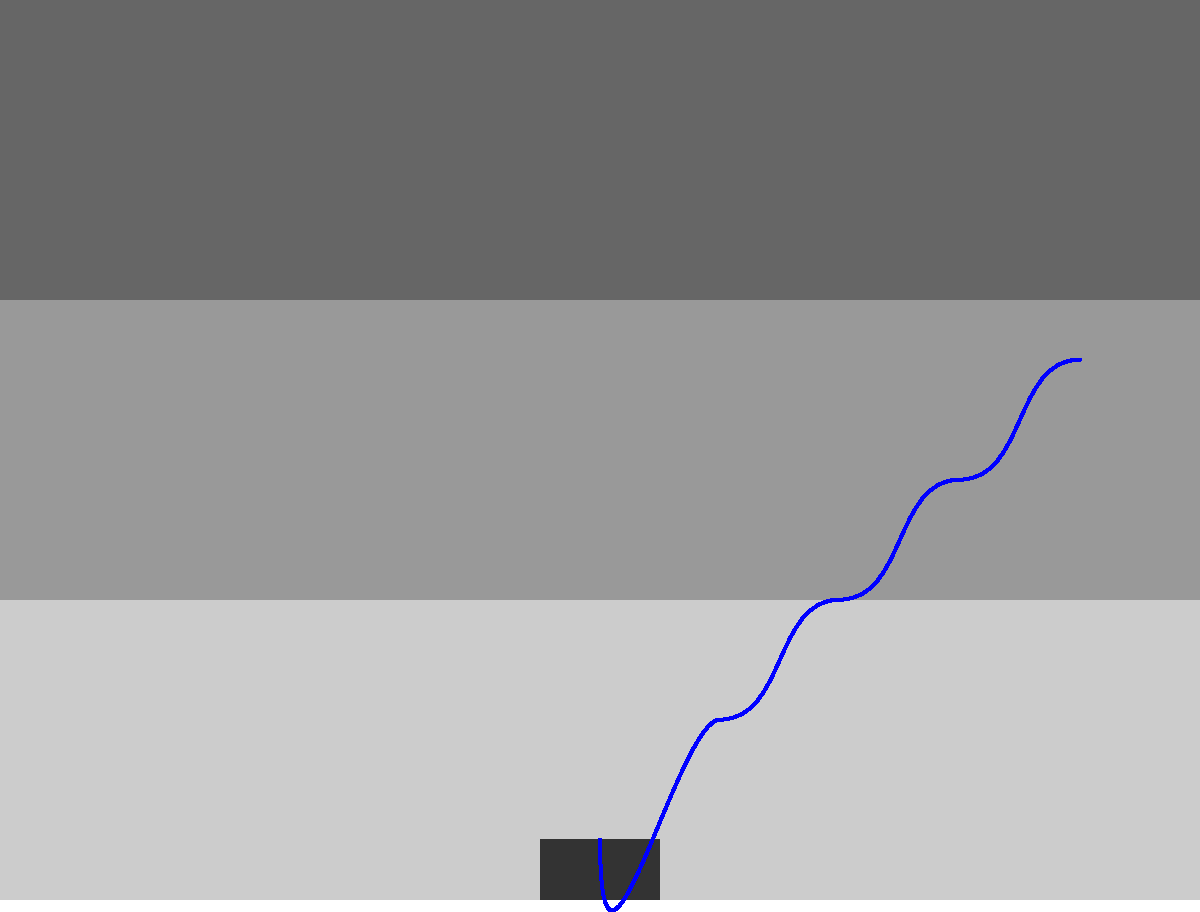In ultrasound imaging for detecting congenital heart defects, the velocity of sound in soft tissue is approximately 1540 m/s. If a defect is detected at a depth of 7.7 cm, what is the time delay between the emission of the ultrasound pulse and the reception of its echo? To solve this problem, we need to follow these steps:

1. Understand the basic principle:
   The ultrasound pulse travels from the transducer to the defect and back.

2. Calculate the total distance traveled:
   Total distance = 2 × depth of the defect
   Total distance = 2 × 7.7 cm = 15.4 cm = 0.154 m

3. Use the formula for velocity:
   $v = \frac{d}{t}$, where $v$ is velocity, $d$ is distance, and $t$ is time

4. Rearrange the formula to solve for time:
   $t = \frac{d}{v}$

5. Substitute the known values:
   $t = \frac{0.154 \text{ m}}{1540 \text{ m/s}}$

6. Calculate the result:
   $t = 0.0001 \text{ s} = 100 \text{ μs}$
Answer: 100 μs 